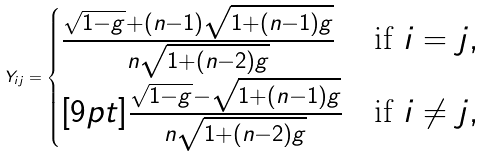Convert formula to latex. <formula><loc_0><loc_0><loc_500><loc_500>Y _ { i j } = \begin{cases} \frac { \sqrt { 1 - g } + ( n - 1 ) \sqrt { 1 + ( n - 1 ) g } } { n \sqrt { 1 + ( n - 2 ) g } } & \text {if $i=j$} , \\ [ 9 p t ] \frac { \sqrt { 1 - g } - \sqrt { 1 + ( n - 1 ) g } } { n \sqrt { 1 + ( n - 2 ) g } } & \text {if $i\neq j$} , \end{cases}</formula> 